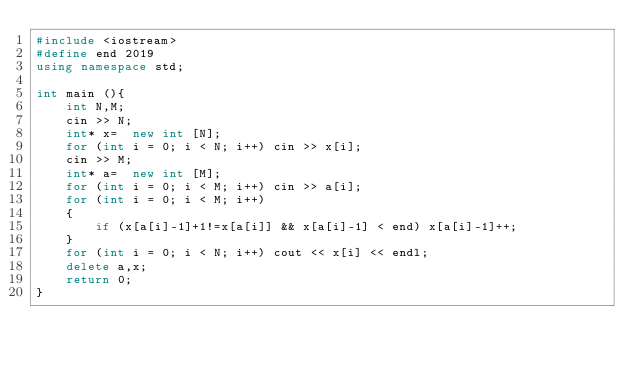Convert code to text. <code><loc_0><loc_0><loc_500><loc_500><_C++_>#include <iostream>
#define end 2019
using namespace std;

int main (){
    int N,M;
    cin >> N;
    int* x=  new int [N];
    for (int i = 0; i < N; i++) cin >> x[i];
    cin >> M;
    int* a=  new int [M];
    for (int i = 0; i < M; i++) cin >> a[i];
    for (int i = 0; i < M; i++)
    {
        if (x[a[i]-1]+1!=x[a[i]] && x[a[i]-1] < end) x[a[i]-1]++;
    }
    for (int i = 0; i < N; i++) cout << x[i] << endl;
    delete a,x;
    return 0;
}
</code> 